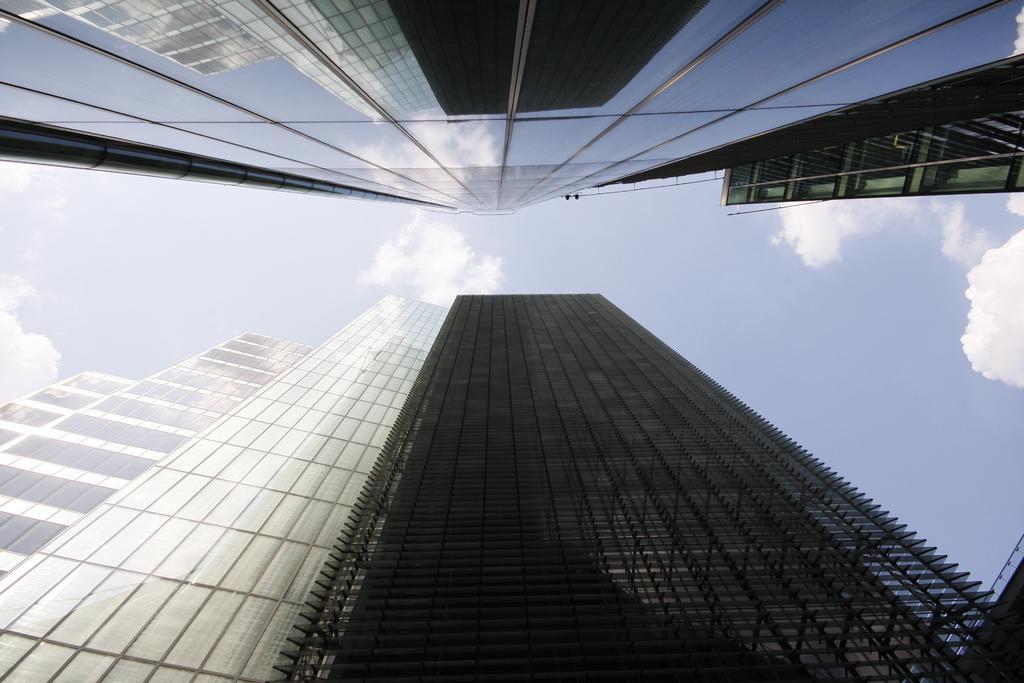Can you describe this image briefly? In this image, we can see some buildings and the sky with clouds. We can also see some glass with the reflection of buildings and the sky. 